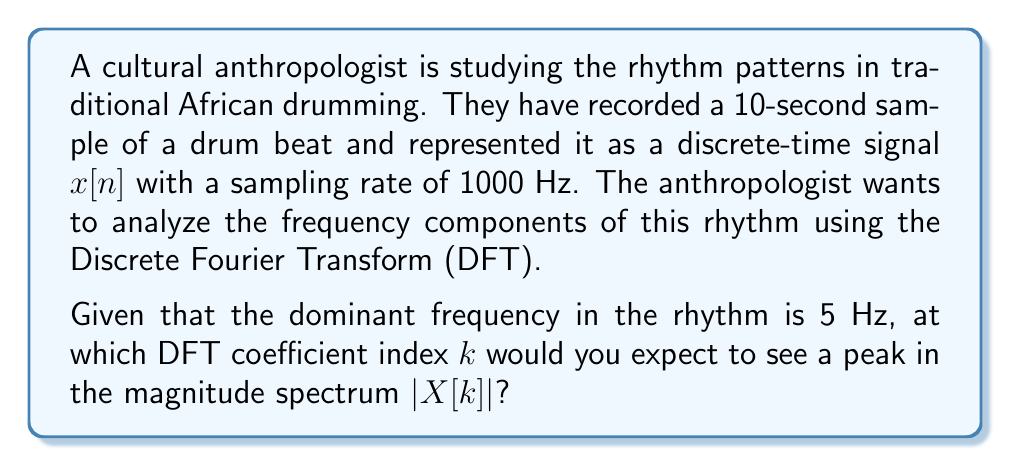Can you solve this math problem? To solve this problem, we need to understand the relationship between the DFT coefficient index and the corresponding frequency. Let's approach this step-by-step:

1) First, we need to calculate the total number of samples $N$ in the signal:
   $$N = \text{Duration} \times \text{Sampling Rate} = 10 \text{ seconds} \times 1000 \text{ Hz} = 10000 \text{ samples}$$

2) In the DFT, the frequency corresponding to the $k$-th coefficient is given by:
   $$f_k = \frac{k \cdot f_s}{N}$$
   where $f_s$ is the sampling frequency and $N$ is the total number of samples.

3) We're looking for the index $k$ where $f_k = 5 \text{ Hz}$. Let's rearrange the equation:
   $$k = \frac{f_k \cdot N}{f_s} = \frac{5 \text{ Hz} \times 10000}{1000 \text{ Hz}} = 50$$

4) Therefore, we expect to see a peak at the DFT coefficient index $k = 50$.

5) As a verification, we can calculate the frequency resolution of the DFT:
   $$\Delta f = \frac{f_s}{N} = \frac{1000 \text{ Hz}}{10000} = 0.1 \text{ Hz}$$
   This means each DFT coefficient represents a frequency bin of 0.1 Hz width, and the 50th coefficient indeed corresponds to 5 Hz.
Answer: The peak in the magnitude spectrum $|X[k]|$ corresponding to the dominant frequency of 5 Hz is expected to occur at DFT coefficient index $k = 50$. 